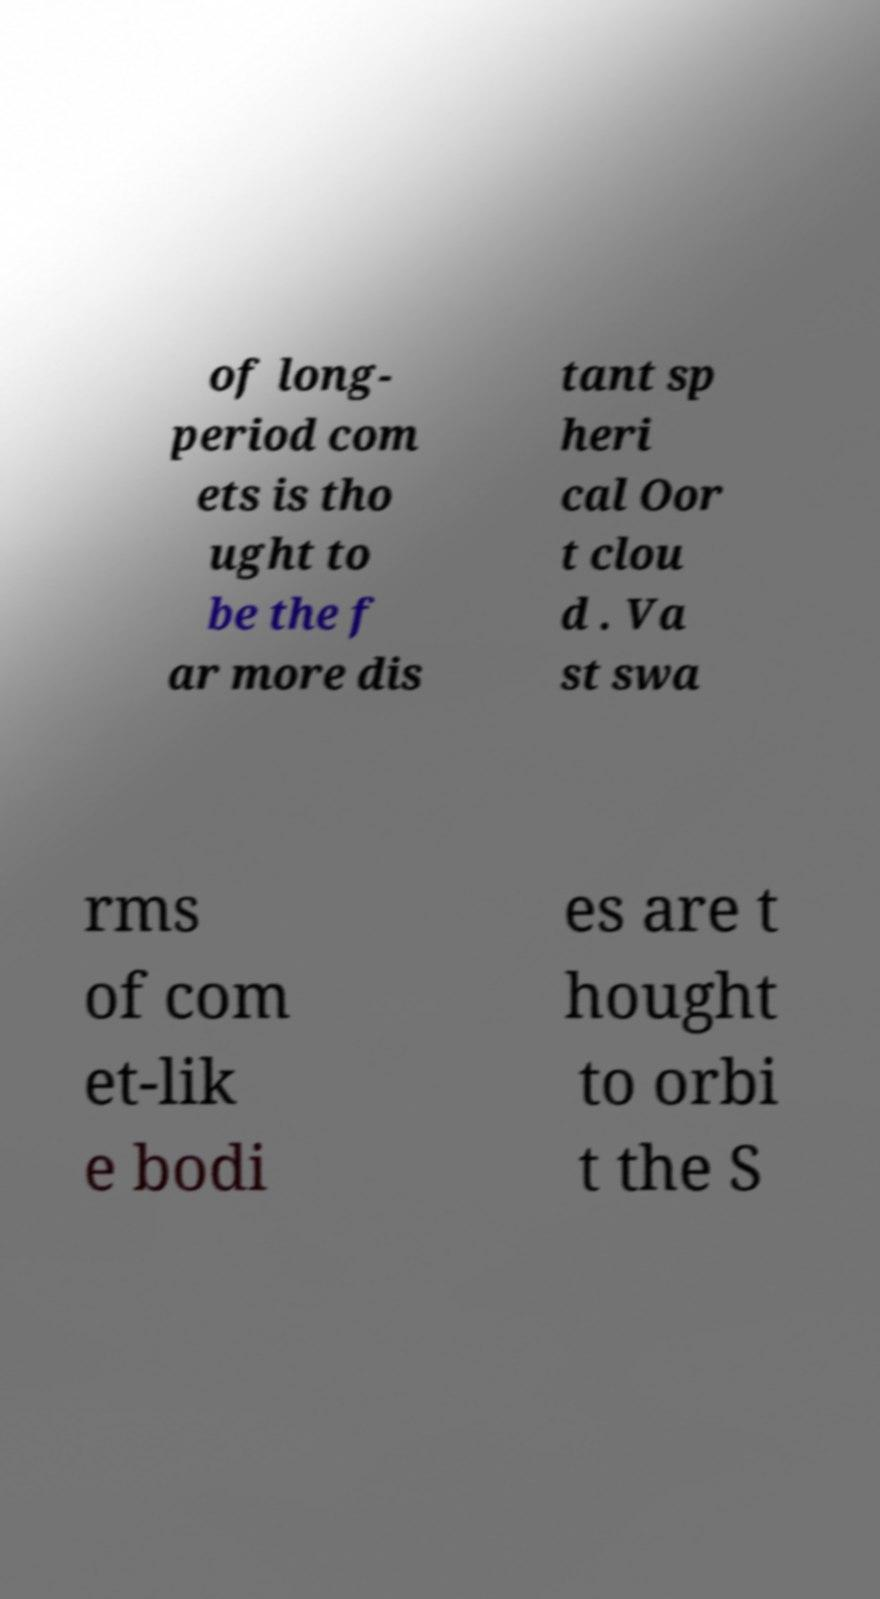What messages or text are displayed in this image? I need them in a readable, typed format. of long- period com ets is tho ught to be the f ar more dis tant sp heri cal Oor t clou d . Va st swa rms of com et-lik e bodi es are t hought to orbi t the S 